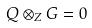Convert formula to latex. <formula><loc_0><loc_0><loc_500><loc_500>Q \otimes _ { Z } G = 0</formula> 